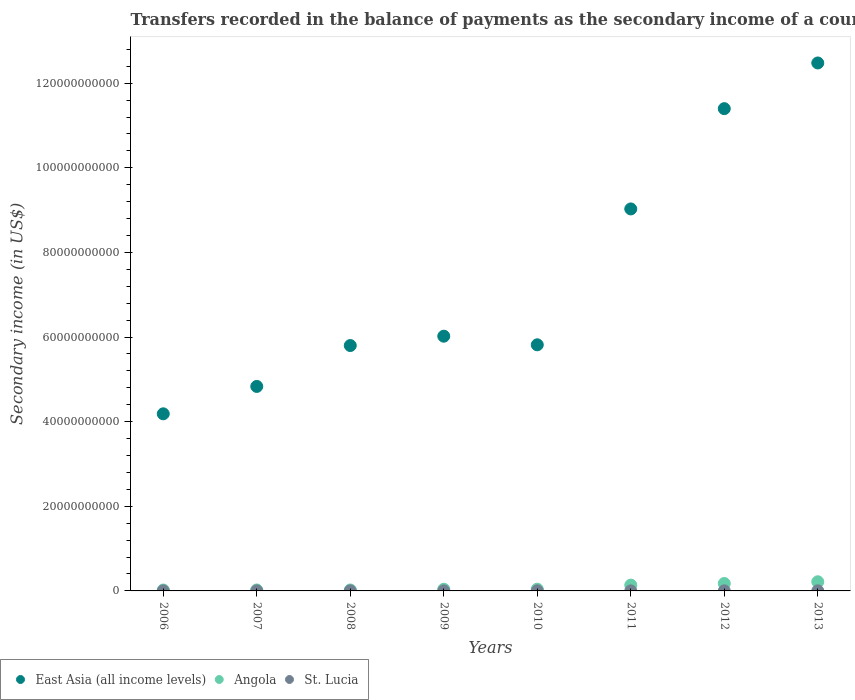How many different coloured dotlines are there?
Offer a very short reply. 3. What is the secondary income of in Angola in 2006?
Provide a succinct answer. 2.14e+08. Across all years, what is the maximum secondary income of in St. Lucia?
Give a very brief answer. 2.24e+07. Across all years, what is the minimum secondary income of in St. Lucia?
Ensure brevity in your answer.  1.12e+07. In which year was the secondary income of in East Asia (all income levels) maximum?
Your answer should be very brief. 2013. In which year was the secondary income of in East Asia (all income levels) minimum?
Provide a succinct answer. 2006. What is the total secondary income of in East Asia (all income levels) in the graph?
Your response must be concise. 5.96e+11. What is the difference between the secondary income of in St. Lucia in 2009 and that in 2010?
Make the answer very short. -2.16e+06. What is the difference between the secondary income of in St. Lucia in 2007 and the secondary income of in East Asia (all income levels) in 2008?
Ensure brevity in your answer.  -5.80e+1. What is the average secondary income of in Angola per year?
Your answer should be compact. 8.47e+08. In the year 2008, what is the difference between the secondary income of in East Asia (all income levels) and secondary income of in Angola?
Your response must be concise. 5.78e+1. What is the ratio of the secondary income of in St. Lucia in 2006 to that in 2013?
Make the answer very short. 0.7. Is the secondary income of in Angola in 2008 less than that in 2009?
Your answer should be compact. Yes. Is the difference between the secondary income of in East Asia (all income levels) in 2008 and 2013 greater than the difference between the secondary income of in Angola in 2008 and 2013?
Your answer should be compact. No. What is the difference between the highest and the second highest secondary income of in St. Lucia?
Give a very brief answer. 2.36e+05. What is the difference between the highest and the lowest secondary income of in Angola?
Offer a terse response. 1.95e+09. Is the sum of the secondary income of in Angola in 2009 and 2012 greater than the maximum secondary income of in East Asia (all income levels) across all years?
Make the answer very short. No. Is it the case that in every year, the sum of the secondary income of in East Asia (all income levels) and secondary income of in St. Lucia  is greater than the secondary income of in Angola?
Your answer should be very brief. Yes. Does the secondary income of in Angola monotonically increase over the years?
Provide a succinct answer. No. Is the secondary income of in Angola strictly less than the secondary income of in East Asia (all income levels) over the years?
Give a very brief answer. Yes. What is the difference between two consecutive major ticks on the Y-axis?
Give a very brief answer. 2.00e+1. Does the graph contain any zero values?
Make the answer very short. No. Does the graph contain grids?
Your response must be concise. No. What is the title of the graph?
Your answer should be compact. Transfers recorded in the balance of payments as the secondary income of a country. Does "Qatar" appear as one of the legend labels in the graph?
Ensure brevity in your answer.  No. What is the label or title of the X-axis?
Your answer should be compact. Years. What is the label or title of the Y-axis?
Offer a terse response. Secondary income (in US$). What is the Secondary income (in US$) of East Asia (all income levels) in 2006?
Your response must be concise. 4.19e+1. What is the Secondary income (in US$) of Angola in 2006?
Provide a short and direct response. 2.14e+08. What is the Secondary income (in US$) of St. Lucia in 2006?
Offer a very short reply. 1.57e+07. What is the Secondary income (in US$) in East Asia (all income levels) in 2007?
Give a very brief answer. 4.83e+1. What is the Secondary income (in US$) in Angola in 2007?
Offer a very short reply. 2.30e+08. What is the Secondary income (in US$) in St. Lucia in 2007?
Make the answer very short. 1.84e+07. What is the Secondary income (in US$) in East Asia (all income levels) in 2008?
Ensure brevity in your answer.  5.80e+1. What is the Secondary income (in US$) of Angola in 2008?
Make the answer very short. 2.22e+08. What is the Secondary income (in US$) of St. Lucia in 2008?
Your answer should be compact. 1.73e+07. What is the Secondary income (in US$) of East Asia (all income levels) in 2009?
Ensure brevity in your answer.  6.02e+1. What is the Secondary income (in US$) in Angola in 2009?
Offer a very short reply. 3.97e+08. What is the Secondary income (in US$) in St. Lucia in 2009?
Offer a very short reply. 1.74e+07. What is the Secondary income (in US$) of East Asia (all income levels) in 2010?
Offer a very short reply. 5.82e+1. What is the Secondary income (in US$) of Angola in 2010?
Your answer should be very brief. 4.13e+08. What is the Secondary income (in US$) in St. Lucia in 2010?
Give a very brief answer. 1.96e+07. What is the Secondary income (in US$) in East Asia (all income levels) in 2011?
Keep it short and to the point. 9.03e+1. What is the Secondary income (in US$) in Angola in 2011?
Your answer should be very brief. 1.38e+09. What is the Secondary income (in US$) of St. Lucia in 2011?
Make the answer very short. 1.12e+07. What is the Secondary income (in US$) in East Asia (all income levels) in 2012?
Keep it short and to the point. 1.14e+11. What is the Secondary income (in US$) in Angola in 2012?
Provide a succinct answer. 1.75e+09. What is the Secondary income (in US$) of St. Lucia in 2012?
Offer a terse response. 2.22e+07. What is the Secondary income (in US$) in East Asia (all income levels) in 2013?
Your answer should be compact. 1.25e+11. What is the Secondary income (in US$) of Angola in 2013?
Offer a terse response. 2.17e+09. What is the Secondary income (in US$) of St. Lucia in 2013?
Your response must be concise. 2.24e+07. Across all years, what is the maximum Secondary income (in US$) of East Asia (all income levels)?
Give a very brief answer. 1.25e+11. Across all years, what is the maximum Secondary income (in US$) of Angola?
Keep it short and to the point. 2.17e+09. Across all years, what is the maximum Secondary income (in US$) of St. Lucia?
Give a very brief answer. 2.24e+07. Across all years, what is the minimum Secondary income (in US$) in East Asia (all income levels)?
Ensure brevity in your answer.  4.19e+1. Across all years, what is the minimum Secondary income (in US$) of Angola?
Offer a terse response. 2.14e+08. Across all years, what is the minimum Secondary income (in US$) in St. Lucia?
Ensure brevity in your answer.  1.12e+07. What is the total Secondary income (in US$) of East Asia (all income levels) in the graph?
Make the answer very short. 5.96e+11. What is the total Secondary income (in US$) of Angola in the graph?
Provide a short and direct response. 6.77e+09. What is the total Secondary income (in US$) of St. Lucia in the graph?
Make the answer very short. 1.44e+08. What is the difference between the Secondary income (in US$) in East Asia (all income levels) in 2006 and that in 2007?
Give a very brief answer. -6.47e+09. What is the difference between the Secondary income (in US$) in Angola in 2006 and that in 2007?
Your answer should be very brief. -1.62e+07. What is the difference between the Secondary income (in US$) of St. Lucia in 2006 and that in 2007?
Provide a short and direct response. -2.65e+06. What is the difference between the Secondary income (in US$) of East Asia (all income levels) in 2006 and that in 2008?
Ensure brevity in your answer.  -1.61e+1. What is the difference between the Secondary income (in US$) in Angola in 2006 and that in 2008?
Give a very brief answer. -8.71e+06. What is the difference between the Secondary income (in US$) of St. Lucia in 2006 and that in 2008?
Your response must be concise. -1.54e+06. What is the difference between the Secondary income (in US$) in East Asia (all income levels) in 2006 and that in 2009?
Your response must be concise. -1.83e+1. What is the difference between the Secondary income (in US$) of Angola in 2006 and that in 2009?
Ensure brevity in your answer.  -1.83e+08. What is the difference between the Secondary income (in US$) of St. Lucia in 2006 and that in 2009?
Keep it short and to the point. -1.71e+06. What is the difference between the Secondary income (in US$) in East Asia (all income levels) in 2006 and that in 2010?
Offer a very short reply. -1.63e+1. What is the difference between the Secondary income (in US$) of Angola in 2006 and that in 2010?
Keep it short and to the point. -1.99e+08. What is the difference between the Secondary income (in US$) of St. Lucia in 2006 and that in 2010?
Your response must be concise. -3.87e+06. What is the difference between the Secondary income (in US$) in East Asia (all income levels) in 2006 and that in 2011?
Offer a very short reply. -4.84e+1. What is the difference between the Secondary income (in US$) of Angola in 2006 and that in 2011?
Your answer should be very brief. -1.16e+09. What is the difference between the Secondary income (in US$) in St. Lucia in 2006 and that in 2011?
Provide a succinct answer. 4.51e+06. What is the difference between the Secondary income (in US$) in East Asia (all income levels) in 2006 and that in 2012?
Keep it short and to the point. -7.21e+1. What is the difference between the Secondary income (in US$) of Angola in 2006 and that in 2012?
Keep it short and to the point. -1.54e+09. What is the difference between the Secondary income (in US$) of St. Lucia in 2006 and that in 2012?
Provide a short and direct response. -6.46e+06. What is the difference between the Secondary income (in US$) of East Asia (all income levels) in 2006 and that in 2013?
Ensure brevity in your answer.  -8.29e+1. What is the difference between the Secondary income (in US$) of Angola in 2006 and that in 2013?
Your answer should be compact. -1.95e+09. What is the difference between the Secondary income (in US$) in St. Lucia in 2006 and that in 2013?
Make the answer very short. -6.69e+06. What is the difference between the Secondary income (in US$) in East Asia (all income levels) in 2007 and that in 2008?
Your answer should be very brief. -9.67e+09. What is the difference between the Secondary income (in US$) in Angola in 2007 and that in 2008?
Offer a very short reply. 7.45e+06. What is the difference between the Secondary income (in US$) in St. Lucia in 2007 and that in 2008?
Give a very brief answer. 1.11e+06. What is the difference between the Secondary income (in US$) in East Asia (all income levels) in 2007 and that in 2009?
Offer a terse response. -1.19e+1. What is the difference between the Secondary income (in US$) in Angola in 2007 and that in 2009?
Provide a short and direct response. -1.67e+08. What is the difference between the Secondary income (in US$) in St. Lucia in 2007 and that in 2009?
Give a very brief answer. 9.37e+05. What is the difference between the Secondary income (in US$) of East Asia (all income levels) in 2007 and that in 2010?
Your answer should be very brief. -9.84e+09. What is the difference between the Secondary income (in US$) of Angola in 2007 and that in 2010?
Give a very brief answer. -1.83e+08. What is the difference between the Secondary income (in US$) of St. Lucia in 2007 and that in 2010?
Offer a very short reply. -1.23e+06. What is the difference between the Secondary income (in US$) of East Asia (all income levels) in 2007 and that in 2011?
Offer a very short reply. -4.20e+1. What is the difference between the Secondary income (in US$) of Angola in 2007 and that in 2011?
Offer a very short reply. -1.15e+09. What is the difference between the Secondary income (in US$) in St. Lucia in 2007 and that in 2011?
Your answer should be compact. 7.16e+06. What is the difference between the Secondary income (in US$) in East Asia (all income levels) in 2007 and that in 2012?
Provide a short and direct response. -6.57e+1. What is the difference between the Secondary income (in US$) in Angola in 2007 and that in 2012?
Provide a short and direct response. -1.52e+09. What is the difference between the Secondary income (in US$) of St. Lucia in 2007 and that in 2012?
Provide a succinct answer. -3.81e+06. What is the difference between the Secondary income (in US$) in East Asia (all income levels) in 2007 and that in 2013?
Your response must be concise. -7.65e+1. What is the difference between the Secondary income (in US$) in Angola in 2007 and that in 2013?
Provide a short and direct response. -1.94e+09. What is the difference between the Secondary income (in US$) of St. Lucia in 2007 and that in 2013?
Provide a short and direct response. -4.05e+06. What is the difference between the Secondary income (in US$) in East Asia (all income levels) in 2008 and that in 2009?
Your answer should be very brief. -2.21e+09. What is the difference between the Secondary income (in US$) in Angola in 2008 and that in 2009?
Provide a short and direct response. -1.75e+08. What is the difference between the Secondary income (in US$) of St. Lucia in 2008 and that in 2009?
Give a very brief answer. -1.74e+05. What is the difference between the Secondary income (in US$) in East Asia (all income levels) in 2008 and that in 2010?
Offer a very short reply. -1.74e+08. What is the difference between the Secondary income (in US$) of Angola in 2008 and that in 2010?
Ensure brevity in your answer.  -1.90e+08. What is the difference between the Secondary income (in US$) in St. Lucia in 2008 and that in 2010?
Keep it short and to the point. -2.34e+06. What is the difference between the Secondary income (in US$) of East Asia (all income levels) in 2008 and that in 2011?
Offer a terse response. -3.23e+1. What is the difference between the Secondary income (in US$) in Angola in 2008 and that in 2011?
Provide a short and direct response. -1.15e+09. What is the difference between the Secondary income (in US$) of St. Lucia in 2008 and that in 2011?
Your answer should be very brief. 6.05e+06. What is the difference between the Secondary income (in US$) of East Asia (all income levels) in 2008 and that in 2012?
Provide a succinct answer. -5.60e+1. What is the difference between the Secondary income (in US$) in Angola in 2008 and that in 2012?
Your answer should be very brief. -1.53e+09. What is the difference between the Secondary income (in US$) of St. Lucia in 2008 and that in 2012?
Your response must be concise. -4.92e+06. What is the difference between the Secondary income (in US$) in East Asia (all income levels) in 2008 and that in 2013?
Provide a succinct answer. -6.68e+1. What is the difference between the Secondary income (in US$) of Angola in 2008 and that in 2013?
Make the answer very short. -1.94e+09. What is the difference between the Secondary income (in US$) of St. Lucia in 2008 and that in 2013?
Provide a succinct answer. -5.16e+06. What is the difference between the Secondary income (in US$) of East Asia (all income levels) in 2009 and that in 2010?
Your response must be concise. 2.03e+09. What is the difference between the Secondary income (in US$) of Angola in 2009 and that in 2010?
Offer a very short reply. -1.57e+07. What is the difference between the Secondary income (in US$) of St. Lucia in 2009 and that in 2010?
Your answer should be very brief. -2.16e+06. What is the difference between the Secondary income (in US$) of East Asia (all income levels) in 2009 and that in 2011?
Provide a short and direct response. -3.01e+1. What is the difference between the Secondary income (in US$) of Angola in 2009 and that in 2011?
Ensure brevity in your answer.  -9.80e+08. What is the difference between the Secondary income (in US$) of St. Lucia in 2009 and that in 2011?
Your answer should be compact. 6.22e+06. What is the difference between the Secondary income (in US$) of East Asia (all income levels) in 2009 and that in 2012?
Your response must be concise. -5.38e+1. What is the difference between the Secondary income (in US$) in Angola in 2009 and that in 2012?
Offer a terse response. -1.36e+09. What is the difference between the Secondary income (in US$) of St. Lucia in 2009 and that in 2012?
Provide a succinct answer. -4.75e+06. What is the difference between the Secondary income (in US$) of East Asia (all income levels) in 2009 and that in 2013?
Your answer should be compact. -6.46e+1. What is the difference between the Secondary income (in US$) in Angola in 2009 and that in 2013?
Offer a terse response. -1.77e+09. What is the difference between the Secondary income (in US$) of St. Lucia in 2009 and that in 2013?
Offer a very short reply. -4.98e+06. What is the difference between the Secondary income (in US$) in East Asia (all income levels) in 2010 and that in 2011?
Ensure brevity in your answer.  -3.21e+1. What is the difference between the Secondary income (in US$) of Angola in 2010 and that in 2011?
Give a very brief answer. -9.65e+08. What is the difference between the Secondary income (in US$) in St. Lucia in 2010 and that in 2011?
Keep it short and to the point. 8.38e+06. What is the difference between the Secondary income (in US$) of East Asia (all income levels) in 2010 and that in 2012?
Ensure brevity in your answer.  -5.58e+1. What is the difference between the Secondary income (in US$) of Angola in 2010 and that in 2012?
Offer a terse response. -1.34e+09. What is the difference between the Secondary income (in US$) in St. Lucia in 2010 and that in 2012?
Make the answer very short. -2.58e+06. What is the difference between the Secondary income (in US$) in East Asia (all income levels) in 2010 and that in 2013?
Ensure brevity in your answer.  -6.66e+1. What is the difference between the Secondary income (in US$) of Angola in 2010 and that in 2013?
Ensure brevity in your answer.  -1.75e+09. What is the difference between the Secondary income (in US$) in St. Lucia in 2010 and that in 2013?
Your answer should be compact. -2.82e+06. What is the difference between the Secondary income (in US$) in East Asia (all income levels) in 2011 and that in 2012?
Give a very brief answer. -2.37e+1. What is the difference between the Secondary income (in US$) of Angola in 2011 and that in 2012?
Your answer should be very brief. -3.77e+08. What is the difference between the Secondary income (in US$) in St. Lucia in 2011 and that in 2012?
Keep it short and to the point. -1.10e+07. What is the difference between the Secondary income (in US$) in East Asia (all income levels) in 2011 and that in 2013?
Provide a succinct answer. -3.45e+1. What is the difference between the Secondary income (in US$) in Angola in 2011 and that in 2013?
Your response must be concise. -7.89e+08. What is the difference between the Secondary income (in US$) of St. Lucia in 2011 and that in 2013?
Ensure brevity in your answer.  -1.12e+07. What is the difference between the Secondary income (in US$) of East Asia (all income levels) in 2012 and that in 2013?
Keep it short and to the point. -1.08e+1. What is the difference between the Secondary income (in US$) of Angola in 2012 and that in 2013?
Offer a very short reply. -4.13e+08. What is the difference between the Secondary income (in US$) in St. Lucia in 2012 and that in 2013?
Your answer should be compact. -2.36e+05. What is the difference between the Secondary income (in US$) in East Asia (all income levels) in 2006 and the Secondary income (in US$) in Angola in 2007?
Offer a very short reply. 4.16e+1. What is the difference between the Secondary income (in US$) of East Asia (all income levels) in 2006 and the Secondary income (in US$) of St. Lucia in 2007?
Make the answer very short. 4.18e+1. What is the difference between the Secondary income (in US$) in Angola in 2006 and the Secondary income (in US$) in St. Lucia in 2007?
Your response must be concise. 1.95e+08. What is the difference between the Secondary income (in US$) of East Asia (all income levels) in 2006 and the Secondary income (in US$) of Angola in 2008?
Ensure brevity in your answer.  4.16e+1. What is the difference between the Secondary income (in US$) in East Asia (all income levels) in 2006 and the Secondary income (in US$) in St. Lucia in 2008?
Ensure brevity in your answer.  4.18e+1. What is the difference between the Secondary income (in US$) in Angola in 2006 and the Secondary income (in US$) in St. Lucia in 2008?
Offer a very short reply. 1.96e+08. What is the difference between the Secondary income (in US$) of East Asia (all income levels) in 2006 and the Secondary income (in US$) of Angola in 2009?
Provide a succinct answer. 4.15e+1. What is the difference between the Secondary income (in US$) of East Asia (all income levels) in 2006 and the Secondary income (in US$) of St. Lucia in 2009?
Give a very brief answer. 4.18e+1. What is the difference between the Secondary income (in US$) of Angola in 2006 and the Secondary income (in US$) of St. Lucia in 2009?
Offer a terse response. 1.96e+08. What is the difference between the Secondary income (in US$) in East Asia (all income levels) in 2006 and the Secondary income (in US$) in Angola in 2010?
Offer a terse response. 4.14e+1. What is the difference between the Secondary income (in US$) of East Asia (all income levels) in 2006 and the Secondary income (in US$) of St. Lucia in 2010?
Offer a very short reply. 4.18e+1. What is the difference between the Secondary income (in US$) in Angola in 2006 and the Secondary income (in US$) in St. Lucia in 2010?
Provide a succinct answer. 1.94e+08. What is the difference between the Secondary income (in US$) in East Asia (all income levels) in 2006 and the Secondary income (in US$) in Angola in 2011?
Your answer should be very brief. 4.05e+1. What is the difference between the Secondary income (in US$) in East Asia (all income levels) in 2006 and the Secondary income (in US$) in St. Lucia in 2011?
Ensure brevity in your answer.  4.18e+1. What is the difference between the Secondary income (in US$) in Angola in 2006 and the Secondary income (in US$) in St. Lucia in 2011?
Give a very brief answer. 2.03e+08. What is the difference between the Secondary income (in US$) in East Asia (all income levels) in 2006 and the Secondary income (in US$) in Angola in 2012?
Give a very brief answer. 4.01e+1. What is the difference between the Secondary income (in US$) of East Asia (all income levels) in 2006 and the Secondary income (in US$) of St. Lucia in 2012?
Keep it short and to the point. 4.18e+1. What is the difference between the Secondary income (in US$) of Angola in 2006 and the Secondary income (in US$) of St. Lucia in 2012?
Your answer should be very brief. 1.92e+08. What is the difference between the Secondary income (in US$) of East Asia (all income levels) in 2006 and the Secondary income (in US$) of Angola in 2013?
Your response must be concise. 3.97e+1. What is the difference between the Secondary income (in US$) in East Asia (all income levels) in 2006 and the Secondary income (in US$) in St. Lucia in 2013?
Keep it short and to the point. 4.18e+1. What is the difference between the Secondary income (in US$) of Angola in 2006 and the Secondary income (in US$) of St. Lucia in 2013?
Provide a short and direct response. 1.91e+08. What is the difference between the Secondary income (in US$) of East Asia (all income levels) in 2007 and the Secondary income (in US$) of Angola in 2008?
Keep it short and to the point. 4.81e+1. What is the difference between the Secondary income (in US$) of East Asia (all income levels) in 2007 and the Secondary income (in US$) of St. Lucia in 2008?
Make the answer very short. 4.83e+1. What is the difference between the Secondary income (in US$) in Angola in 2007 and the Secondary income (in US$) in St. Lucia in 2008?
Offer a very short reply. 2.13e+08. What is the difference between the Secondary income (in US$) of East Asia (all income levels) in 2007 and the Secondary income (in US$) of Angola in 2009?
Make the answer very short. 4.79e+1. What is the difference between the Secondary income (in US$) of East Asia (all income levels) in 2007 and the Secondary income (in US$) of St. Lucia in 2009?
Give a very brief answer. 4.83e+1. What is the difference between the Secondary income (in US$) of Angola in 2007 and the Secondary income (in US$) of St. Lucia in 2009?
Your response must be concise. 2.12e+08. What is the difference between the Secondary income (in US$) of East Asia (all income levels) in 2007 and the Secondary income (in US$) of Angola in 2010?
Give a very brief answer. 4.79e+1. What is the difference between the Secondary income (in US$) of East Asia (all income levels) in 2007 and the Secondary income (in US$) of St. Lucia in 2010?
Keep it short and to the point. 4.83e+1. What is the difference between the Secondary income (in US$) in Angola in 2007 and the Secondary income (in US$) in St. Lucia in 2010?
Provide a succinct answer. 2.10e+08. What is the difference between the Secondary income (in US$) in East Asia (all income levels) in 2007 and the Secondary income (in US$) in Angola in 2011?
Provide a succinct answer. 4.70e+1. What is the difference between the Secondary income (in US$) in East Asia (all income levels) in 2007 and the Secondary income (in US$) in St. Lucia in 2011?
Provide a succinct answer. 4.83e+1. What is the difference between the Secondary income (in US$) in Angola in 2007 and the Secondary income (in US$) in St. Lucia in 2011?
Give a very brief answer. 2.19e+08. What is the difference between the Secondary income (in US$) in East Asia (all income levels) in 2007 and the Secondary income (in US$) in Angola in 2012?
Provide a succinct answer. 4.66e+1. What is the difference between the Secondary income (in US$) in East Asia (all income levels) in 2007 and the Secondary income (in US$) in St. Lucia in 2012?
Offer a very short reply. 4.83e+1. What is the difference between the Secondary income (in US$) in Angola in 2007 and the Secondary income (in US$) in St. Lucia in 2012?
Your answer should be compact. 2.08e+08. What is the difference between the Secondary income (in US$) in East Asia (all income levels) in 2007 and the Secondary income (in US$) in Angola in 2013?
Your answer should be very brief. 4.62e+1. What is the difference between the Secondary income (in US$) in East Asia (all income levels) in 2007 and the Secondary income (in US$) in St. Lucia in 2013?
Your answer should be compact. 4.83e+1. What is the difference between the Secondary income (in US$) of Angola in 2007 and the Secondary income (in US$) of St. Lucia in 2013?
Provide a succinct answer. 2.07e+08. What is the difference between the Secondary income (in US$) of East Asia (all income levels) in 2008 and the Secondary income (in US$) of Angola in 2009?
Your response must be concise. 5.76e+1. What is the difference between the Secondary income (in US$) of East Asia (all income levels) in 2008 and the Secondary income (in US$) of St. Lucia in 2009?
Provide a short and direct response. 5.80e+1. What is the difference between the Secondary income (in US$) in Angola in 2008 and the Secondary income (in US$) in St. Lucia in 2009?
Provide a succinct answer. 2.05e+08. What is the difference between the Secondary income (in US$) in East Asia (all income levels) in 2008 and the Secondary income (in US$) in Angola in 2010?
Ensure brevity in your answer.  5.76e+1. What is the difference between the Secondary income (in US$) of East Asia (all income levels) in 2008 and the Secondary income (in US$) of St. Lucia in 2010?
Ensure brevity in your answer.  5.80e+1. What is the difference between the Secondary income (in US$) in Angola in 2008 and the Secondary income (in US$) in St. Lucia in 2010?
Make the answer very short. 2.03e+08. What is the difference between the Secondary income (in US$) of East Asia (all income levels) in 2008 and the Secondary income (in US$) of Angola in 2011?
Your answer should be very brief. 5.66e+1. What is the difference between the Secondary income (in US$) in East Asia (all income levels) in 2008 and the Secondary income (in US$) in St. Lucia in 2011?
Provide a succinct answer. 5.80e+1. What is the difference between the Secondary income (in US$) of Angola in 2008 and the Secondary income (in US$) of St. Lucia in 2011?
Keep it short and to the point. 2.11e+08. What is the difference between the Secondary income (in US$) of East Asia (all income levels) in 2008 and the Secondary income (in US$) of Angola in 2012?
Give a very brief answer. 5.62e+1. What is the difference between the Secondary income (in US$) in East Asia (all income levels) in 2008 and the Secondary income (in US$) in St. Lucia in 2012?
Ensure brevity in your answer.  5.80e+1. What is the difference between the Secondary income (in US$) in Angola in 2008 and the Secondary income (in US$) in St. Lucia in 2012?
Offer a very short reply. 2.00e+08. What is the difference between the Secondary income (in US$) in East Asia (all income levels) in 2008 and the Secondary income (in US$) in Angola in 2013?
Make the answer very short. 5.58e+1. What is the difference between the Secondary income (in US$) of East Asia (all income levels) in 2008 and the Secondary income (in US$) of St. Lucia in 2013?
Your answer should be compact. 5.80e+1. What is the difference between the Secondary income (in US$) of Angola in 2008 and the Secondary income (in US$) of St. Lucia in 2013?
Keep it short and to the point. 2.00e+08. What is the difference between the Secondary income (in US$) in East Asia (all income levels) in 2009 and the Secondary income (in US$) in Angola in 2010?
Your answer should be compact. 5.98e+1. What is the difference between the Secondary income (in US$) in East Asia (all income levels) in 2009 and the Secondary income (in US$) in St. Lucia in 2010?
Offer a very short reply. 6.02e+1. What is the difference between the Secondary income (in US$) in Angola in 2009 and the Secondary income (in US$) in St. Lucia in 2010?
Your answer should be very brief. 3.77e+08. What is the difference between the Secondary income (in US$) of East Asia (all income levels) in 2009 and the Secondary income (in US$) of Angola in 2011?
Make the answer very short. 5.88e+1. What is the difference between the Secondary income (in US$) of East Asia (all income levels) in 2009 and the Secondary income (in US$) of St. Lucia in 2011?
Ensure brevity in your answer.  6.02e+1. What is the difference between the Secondary income (in US$) of Angola in 2009 and the Secondary income (in US$) of St. Lucia in 2011?
Ensure brevity in your answer.  3.86e+08. What is the difference between the Secondary income (in US$) in East Asia (all income levels) in 2009 and the Secondary income (in US$) in Angola in 2012?
Offer a terse response. 5.85e+1. What is the difference between the Secondary income (in US$) of East Asia (all income levels) in 2009 and the Secondary income (in US$) of St. Lucia in 2012?
Offer a very short reply. 6.02e+1. What is the difference between the Secondary income (in US$) of Angola in 2009 and the Secondary income (in US$) of St. Lucia in 2012?
Make the answer very short. 3.75e+08. What is the difference between the Secondary income (in US$) in East Asia (all income levels) in 2009 and the Secondary income (in US$) in Angola in 2013?
Your response must be concise. 5.80e+1. What is the difference between the Secondary income (in US$) of East Asia (all income levels) in 2009 and the Secondary income (in US$) of St. Lucia in 2013?
Provide a succinct answer. 6.02e+1. What is the difference between the Secondary income (in US$) in Angola in 2009 and the Secondary income (in US$) in St. Lucia in 2013?
Your answer should be compact. 3.75e+08. What is the difference between the Secondary income (in US$) of East Asia (all income levels) in 2010 and the Secondary income (in US$) of Angola in 2011?
Your answer should be very brief. 5.68e+1. What is the difference between the Secondary income (in US$) of East Asia (all income levels) in 2010 and the Secondary income (in US$) of St. Lucia in 2011?
Provide a succinct answer. 5.82e+1. What is the difference between the Secondary income (in US$) of Angola in 2010 and the Secondary income (in US$) of St. Lucia in 2011?
Your response must be concise. 4.02e+08. What is the difference between the Secondary income (in US$) of East Asia (all income levels) in 2010 and the Secondary income (in US$) of Angola in 2012?
Provide a succinct answer. 5.64e+1. What is the difference between the Secondary income (in US$) of East Asia (all income levels) in 2010 and the Secondary income (in US$) of St. Lucia in 2012?
Ensure brevity in your answer.  5.81e+1. What is the difference between the Secondary income (in US$) of Angola in 2010 and the Secondary income (in US$) of St. Lucia in 2012?
Your response must be concise. 3.91e+08. What is the difference between the Secondary income (in US$) in East Asia (all income levels) in 2010 and the Secondary income (in US$) in Angola in 2013?
Offer a very short reply. 5.60e+1. What is the difference between the Secondary income (in US$) of East Asia (all income levels) in 2010 and the Secondary income (in US$) of St. Lucia in 2013?
Ensure brevity in your answer.  5.81e+1. What is the difference between the Secondary income (in US$) in Angola in 2010 and the Secondary income (in US$) in St. Lucia in 2013?
Provide a succinct answer. 3.90e+08. What is the difference between the Secondary income (in US$) in East Asia (all income levels) in 2011 and the Secondary income (in US$) in Angola in 2012?
Keep it short and to the point. 8.85e+1. What is the difference between the Secondary income (in US$) of East Asia (all income levels) in 2011 and the Secondary income (in US$) of St. Lucia in 2012?
Give a very brief answer. 9.03e+1. What is the difference between the Secondary income (in US$) in Angola in 2011 and the Secondary income (in US$) in St. Lucia in 2012?
Provide a succinct answer. 1.36e+09. What is the difference between the Secondary income (in US$) in East Asia (all income levels) in 2011 and the Secondary income (in US$) in Angola in 2013?
Offer a terse response. 8.81e+1. What is the difference between the Secondary income (in US$) of East Asia (all income levels) in 2011 and the Secondary income (in US$) of St. Lucia in 2013?
Provide a short and direct response. 9.03e+1. What is the difference between the Secondary income (in US$) in Angola in 2011 and the Secondary income (in US$) in St. Lucia in 2013?
Keep it short and to the point. 1.35e+09. What is the difference between the Secondary income (in US$) in East Asia (all income levels) in 2012 and the Secondary income (in US$) in Angola in 2013?
Offer a terse response. 1.12e+11. What is the difference between the Secondary income (in US$) in East Asia (all income levels) in 2012 and the Secondary income (in US$) in St. Lucia in 2013?
Offer a terse response. 1.14e+11. What is the difference between the Secondary income (in US$) of Angola in 2012 and the Secondary income (in US$) of St. Lucia in 2013?
Offer a terse response. 1.73e+09. What is the average Secondary income (in US$) in East Asia (all income levels) per year?
Your answer should be compact. 7.45e+1. What is the average Secondary income (in US$) of Angola per year?
Your answer should be very brief. 8.47e+08. What is the average Secondary income (in US$) of St. Lucia per year?
Provide a succinct answer. 1.80e+07. In the year 2006, what is the difference between the Secondary income (in US$) in East Asia (all income levels) and Secondary income (in US$) in Angola?
Provide a short and direct response. 4.16e+1. In the year 2006, what is the difference between the Secondary income (in US$) in East Asia (all income levels) and Secondary income (in US$) in St. Lucia?
Your answer should be compact. 4.18e+1. In the year 2006, what is the difference between the Secondary income (in US$) in Angola and Secondary income (in US$) in St. Lucia?
Your response must be concise. 1.98e+08. In the year 2007, what is the difference between the Secondary income (in US$) in East Asia (all income levels) and Secondary income (in US$) in Angola?
Ensure brevity in your answer.  4.81e+1. In the year 2007, what is the difference between the Secondary income (in US$) in East Asia (all income levels) and Secondary income (in US$) in St. Lucia?
Offer a very short reply. 4.83e+1. In the year 2007, what is the difference between the Secondary income (in US$) in Angola and Secondary income (in US$) in St. Lucia?
Provide a short and direct response. 2.12e+08. In the year 2008, what is the difference between the Secondary income (in US$) in East Asia (all income levels) and Secondary income (in US$) in Angola?
Offer a very short reply. 5.78e+1. In the year 2008, what is the difference between the Secondary income (in US$) in East Asia (all income levels) and Secondary income (in US$) in St. Lucia?
Your answer should be compact. 5.80e+1. In the year 2008, what is the difference between the Secondary income (in US$) of Angola and Secondary income (in US$) of St. Lucia?
Offer a terse response. 2.05e+08. In the year 2009, what is the difference between the Secondary income (in US$) in East Asia (all income levels) and Secondary income (in US$) in Angola?
Your answer should be compact. 5.98e+1. In the year 2009, what is the difference between the Secondary income (in US$) in East Asia (all income levels) and Secondary income (in US$) in St. Lucia?
Give a very brief answer. 6.02e+1. In the year 2009, what is the difference between the Secondary income (in US$) of Angola and Secondary income (in US$) of St. Lucia?
Provide a succinct answer. 3.80e+08. In the year 2010, what is the difference between the Secondary income (in US$) of East Asia (all income levels) and Secondary income (in US$) of Angola?
Give a very brief answer. 5.78e+1. In the year 2010, what is the difference between the Secondary income (in US$) in East Asia (all income levels) and Secondary income (in US$) in St. Lucia?
Your answer should be very brief. 5.82e+1. In the year 2010, what is the difference between the Secondary income (in US$) in Angola and Secondary income (in US$) in St. Lucia?
Offer a very short reply. 3.93e+08. In the year 2011, what is the difference between the Secondary income (in US$) of East Asia (all income levels) and Secondary income (in US$) of Angola?
Ensure brevity in your answer.  8.89e+1. In the year 2011, what is the difference between the Secondary income (in US$) in East Asia (all income levels) and Secondary income (in US$) in St. Lucia?
Provide a succinct answer. 9.03e+1. In the year 2011, what is the difference between the Secondary income (in US$) of Angola and Secondary income (in US$) of St. Lucia?
Provide a short and direct response. 1.37e+09. In the year 2012, what is the difference between the Secondary income (in US$) of East Asia (all income levels) and Secondary income (in US$) of Angola?
Make the answer very short. 1.12e+11. In the year 2012, what is the difference between the Secondary income (in US$) in East Asia (all income levels) and Secondary income (in US$) in St. Lucia?
Provide a short and direct response. 1.14e+11. In the year 2012, what is the difference between the Secondary income (in US$) of Angola and Secondary income (in US$) of St. Lucia?
Your answer should be compact. 1.73e+09. In the year 2013, what is the difference between the Secondary income (in US$) of East Asia (all income levels) and Secondary income (in US$) of Angola?
Give a very brief answer. 1.23e+11. In the year 2013, what is the difference between the Secondary income (in US$) of East Asia (all income levels) and Secondary income (in US$) of St. Lucia?
Give a very brief answer. 1.25e+11. In the year 2013, what is the difference between the Secondary income (in US$) in Angola and Secondary income (in US$) in St. Lucia?
Provide a succinct answer. 2.14e+09. What is the ratio of the Secondary income (in US$) of East Asia (all income levels) in 2006 to that in 2007?
Offer a very short reply. 0.87. What is the ratio of the Secondary income (in US$) of Angola in 2006 to that in 2007?
Your answer should be very brief. 0.93. What is the ratio of the Secondary income (in US$) of St. Lucia in 2006 to that in 2007?
Give a very brief answer. 0.86. What is the ratio of the Secondary income (in US$) in East Asia (all income levels) in 2006 to that in 2008?
Your answer should be compact. 0.72. What is the ratio of the Secondary income (in US$) in Angola in 2006 to that in 2008?
Your answer should be very brief. 0.96. What is the ratio of the Secondary income (in US$) in St. Lucia in 2006 to that in 2008?
Your answer should be very brief. 0.91. What is the ratio of the Secondary income (in US$) of East Asia (all income levels) in 2006 to that in 2009?
Keep it short and to the point. 0.7. What is the ratio of the Secondary income (in US$) of Angola in 2006 to that in 2009?
Your response must be concise. 0.54. What is the ratio of the Secondary income (in US$) of St. Lucia in 2006 to that in 2009?
Your answer should be very brief. 0.9. What is the ratio of the Secondary income (in US$) of East Asia (all income levels) in 2006 to that in 2010?
Your answer should be compact. 0.72. What is the ratio of the Secondary income (in US$) of Angola in 2006 to that in 2010?
Keep it short and to the point. 0.52. What is the ratio of the Secondary income (in US$) of St. Lucia in 2006 to that in 2010?
Provide a short and direct response. 0.8. What is the ratio of the Secondary income (in US$) of East Asia (all income levels) in 2006 to that in 2011?
Provide a succinct answer. 0.46. What is the ratio of the Secondary income (in US$) in Angola in 2006 to that in 2011?
Keep it short and to the point. 0.16. What is the ratio of the Secondary income (in US$) of St. Lucia in 2006 to that in 2011?
Provide a succinct answer. 1.4. What is the ratio of the Secondary income (in US$) in East Asia (all income levels) in 2006 to that in 2012?
Make the answer very short. 0.37. What is the ratio of the Secondary income (in US$) in Angola in 2006 to that in 2012?
Provide a succinct answer. 0.12. What is the ratio of the Secondary income (in US$) of St. Lucia in 2006 to that in 2012?
Give a very brief answer. 0.71. What is the ratio of the Secondary income (in US$) in East Asia (all income levels) in 2006 to that in 2013?
Your response must be concise. 0.34. What is the ratio of the Secondary income (in US$) in Angola in 2006 to that in 2013?
Your response must be concise. 0.1. What is the ratio of the Secondary income (in US$) of St. Lucia in 2006 to that in 2013?
Offer a very short reply. 0.7. What is the ratio of the Secondary income (in US$) in East Asia (all income levels) in 2007 to that in 2008?
Offer a very short reply. 0.83. What is the ratio of the Secondary income (in US$) in Angola in 2007 to that in 2008?
Your response must be concise. 1.03. What is the ratio of the Secondary income (in US$) in St. Lucia in 2007 to that in 2008?
Make the answer very short. 1.06. What is the ratio of the Secondary income (in US$) in East Asia (all income levels) in 2007 to that in 2009?
Your answer should be very brief. 0.8. What is the ratio of the Secondary income (in US$) of Angola in 2007 to that in 2009?
Make the answer very short. 0.58. What is the ratio of the Secondary income (in US$) in St. Lucia in 2007 to that in 2009?
Offer a very short reply. 1.05. What is the ratio of the Secondary income (in US$) in East Asia (all income levels) in 2007 to that in 2010?
Your answer should be compact. 0.83. What is the ratio of the Secondary income (in US$) in Angola in 2007 to that in 2010?
Make the answer very short. 0.56. What is the ratio of the Secondary income (in US$) of St. Lucia in 2007 to that in 2010?
Offer a terse response. 0.94. What is the ratio of the Secondary income (in US$) in East Asia (all income levels) in 2007 to that in 2011?
Keep it short and to the point. 0.54. What is the ratio of the Secondary income (in US$) in Angola in 2007 to that in 2011?
Your answer should be compact. 0.17. What is the ratio of the Secondary income (in US$) of St. Lucia in 2007 to that in 2011?
Ensure brevity in your answer.  1.64. What is the ratio of the Secondary income (in US$) in East Asia (all income levels) in 2007 to that in 2012?
Provide a short and direct response. 0.42. What is the ratio of the Secondary income (in US$) in Angola in 2007 to that in 2012?
Offer a terse response. 0.13. What is the ratio of the Secondary income (in US$) in St. Lucia in 2007 to that in 2012?
Provide a short and direct response. 0.83. What is the ratio of the Secondary income (in US$) in East Asia (all income levels) in 2007 to that in 2013?
Provide a succinct answer. 0.39. What is the ratio of the Secondary income (in US$) in Angola in 2007 to that in 2013?
Ensure brevity in your answer.  0.11. What is the ratio of the Secondary income (in US$) of St. Lucia in 2007 to that in 2013?
Provide a succinct answer. 0.82. What is the ratio of the Secondary income (in US$) in East Asia (all income levels) in 2008 to that in 2009?
Your answer should be very brief. 0.96. What is the ratio of the Secondary income (in US$) in Angola in 2008 to that in 2009?
Make the answer very short. 0.56. What is the ratio of the Secondary income (in US$) of St. Lucia in 2008 to that in 2009?
Your answer should be compact. 0.99. What is the ratio of the Secondary income (in US$) in Angola in 2008 to that in 2010?
Your answer should be compact. 0.54. What is the ratio of the Secondary income (in US$) in St. Lucia in 2008 to that in 2010?
Provide a succinct answer. 0.88. What is the ratio of the Secondary income (in US$) of East Asia (all income levels) in 2008 to that in 2011?
Offer a terse response. 0.64. What is the ratio of the Secondary income (in US$) of Angola in 2008 to that in 2011?
Your answer should be very brief. 0.16. What is the ratio of the Secondary income (in US$) of St. Lucia in 2008 to that in 2011?
Your answer should be very brief. 1.54. What is the ratio of the Secondary income (in US$) of East Asia (all income levels) in 2008 to that in 2012?
Give a very brief answer. 0.51. What is the ratio of the Secondary income (in US$) in Angola in 2008 to that in 2012?
Provide a short and direct response. 0.13. What is the ratio of the Secondary income (in US$) in St. Lucia in 2008 to that in 2012?
Keep it short and to the point. 0.78. What is the ratio of the Secondary income (in US$) in East Asia (all income levels) in 2008 to that in 2013?
Your response must be concise. 0.46. What is the ratio of the Secondary income (in US$) in Angola in 2008 to that in 2013?
Give a very brief answer. 0.1. What is the ratio of the Secondary income (in US$) of St. Lucia in 2008 to that in 2013?
Offer a very short reply. 0.77. What is the ratio of the Secondary income (in US$) of East Asia (all income levels) in 2009 to that in 2010?
Ensure brevity in your answer.  1.03. What is the ratio of the Secondary income (in US$) in St. Lucia in 2009 to that in 2010?
Ensure brevity in your answer.  0.89. What is the ratio of the Secondary income (in US$) of East Asia (all income levels) in 2009 to that in 2011?
Offer a very short reply. 0.67. What is the ratio of the Secondary income (in US$) of Angola in 2009 to that in 2011?
Keep it short and to the point. 0.29. What is the ratio of the Secondary income (in US$) in St. Lucia in 2009 to that in 2011?
Your response must be concise. 1.55. What is the ratio of the Secondary income (in US$) of East Asia (all income levels) in 2009 to that in 2012?
Provide a succinct answer. 0.53. What is the ratio of the Secondary income (in US$) of Angola in 2009 to that in 2012?
Offer a very short reply. 0.23. What is the ratio of the Secondary income (in US$) of St. Lucia in 2009 to that in 2012?
Give a very brief answer. 0.79. What is the ratio of the Secondary income (in US$) in East Asia (all income levels) in 2009 to that in 2013?
Provide a short and direct response. 0.48. What is the ratio of the Secondary income (in US$) in Angola in 2009 to that in 2013?
Ensure brevity in your answer.  0.18. What is the ratio of the Secondary income (in US$) of St. Lucia in 2009 to that in 2013?
Offer a terse response. 0.78. What is the ratio of the Secondary income (in US$) of East Asia (all income levels) in 2010 to that in 2011?
Offer a very short reply. 0.64. What is the ratio of the Secondary income (in US$) in Angola in 2010 to that in 2011?
Your response must be concise. 0.3. What is the ratio of the Secondary income (in US$) in St. Lucia in 2010 to that in 2011?
Keep it short and to the point. 1.75. What is the ratio of the Secondary income (in US$) of East Asia (all income levels) in 2010 to that in 2012?
Your answer should be very brief. 0.51. What is the ratio of the Secondary income (in US$) in Angola in 2010 to that in 2012?
Give a very brief answer. 0.24. What is the ratio of the Secondary income (in US$) in St. Lucia in 2010 to that in 2012?
Ensure brevity in your answer.  0.88. What is the ratio of the Secondary income (in US$) in East Asia (all income levels) in 2010 to that in 2013?
Make the answer very short. 0.47. What is the ratio of the Secondary income (in US$) in Angola in 2010 to that in 2013?
Offer a terse response. 0.19. What is the ratio of the Secondary income (in US$) of St. Lucia in 2010 to that in 2013?
Your response must be concise. 0.87. What is the ratio of the Secondary income (in US$) in East Asia (all income levels) in 2011 to that in 2012?
Your answer should be very brief. 0.79. What is the ratio of the Secondary income (in US$) of Angola in 2011 to that in 2012?
Provide a short and direct response. 0.79. What is the ratio of the Secondary income (in US$) in St. Lucia in 2011 to that in 2012?
Ensure brevity in your answer.  0.51. What is the ratio of the Secondary income (in US$) of East Asia (all income levels) in 2011 to that in 2013?
Ensure brevity in your answer.  0.72. What is the ratio of the Secondary income (in US$) in Angola in 2011 to that in 2013?
Offer a terse response. 0.64. What is the ratio of the Secondary income (in US$) in St. Lucia in 2011 to that in 2013?
Ensure brevity in your answer.  0.5. What is the ratio of the Secondary income (in US$) of East Asia (all income levels) in 2012 to that in 2013?
Provide a succinct answer. 0.91. What is the ratio of the Secondary income (in US$) of Angola in 2012 to that in 2013?
Ensure brevity in your answer.  0.81. What is the ratio of the Secondary income (in US$) of St. Lucia in 2012 to that in 2013?
Provide a short and direct response. 0.99. What is the difference between the highest and the second highest Secondary income (in US$) in East Asia (all income levels)?
Give a very brief answer. 1.08e+1. What is the difference between the highest and the second highest Secondary income (in US$) in Angola?
Provide a short and direct response. 4.13e+08. What is the difference between the highest and the second highest Secondary income (in US$) in St. Lucia?
Give a very brief answer. 2.36e+05. What is the difference between the highest and the lowest Secondary income (in US$) in East Asia (all income levels)?
Provide a short and direct response. 8.29e+1. What is the difference between the highest and the lowest Secondary income (in US$) of Angola?
Your response must be concise. 1.95e+09. What is the difference between the highest and the lowest Secondary income (in US$) in St. Lucia?
Offer a terse response. 1.12e+07. 